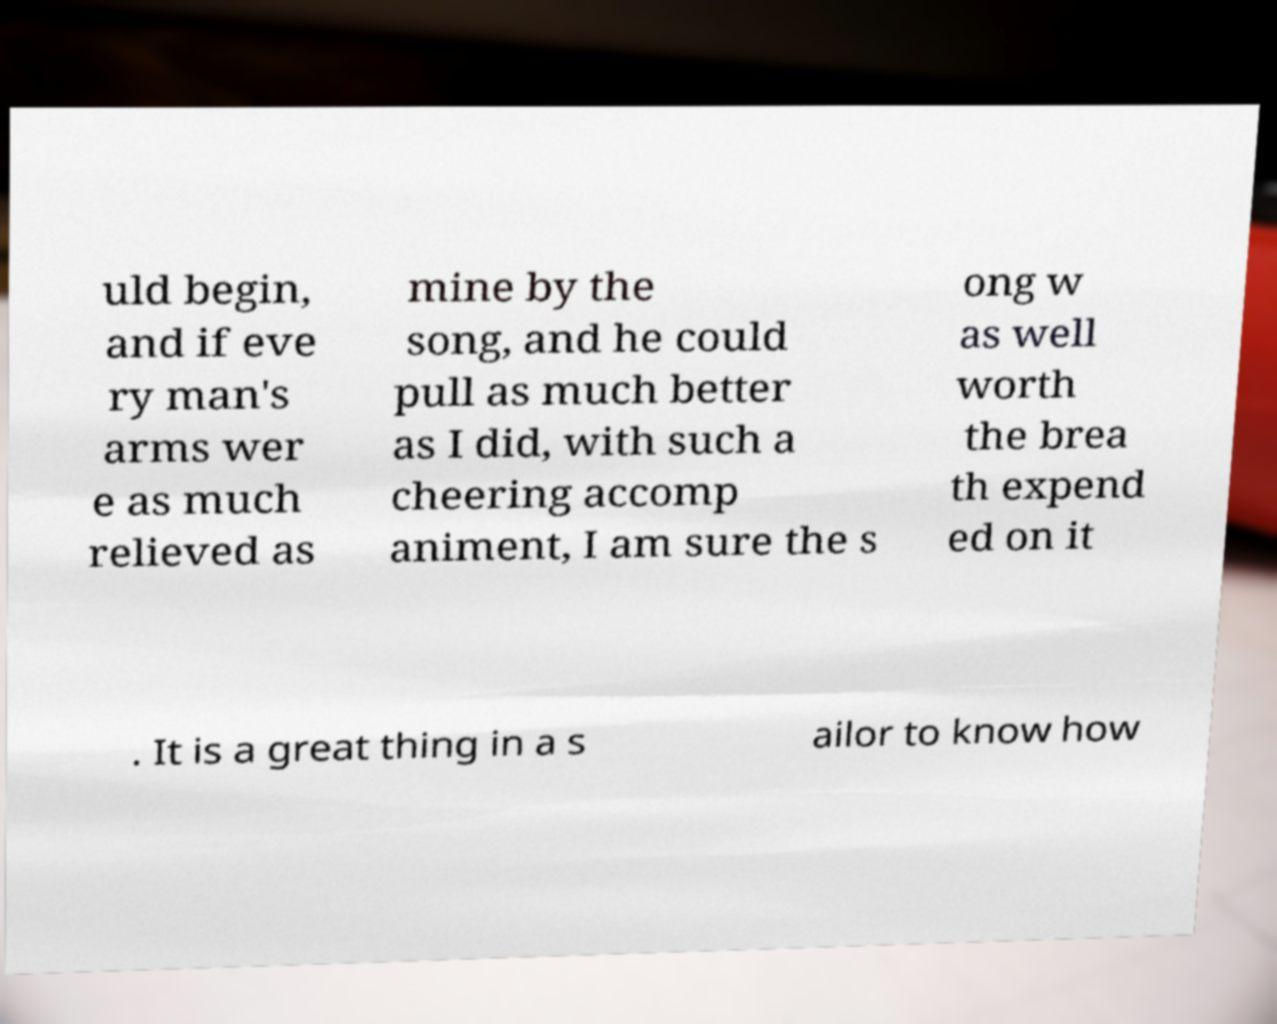There's text embedded in this image that I need extracted. Can you transcribe it verbatim? uld begin, and if eve ry man's arms wer e as much relieved as mine by the song, and he could pull as much better as I did, with such a cheering accomp animent, I am sure the s ong w as well worth the brea th expend ed on it . It is a great thing in a s ailor to know how 